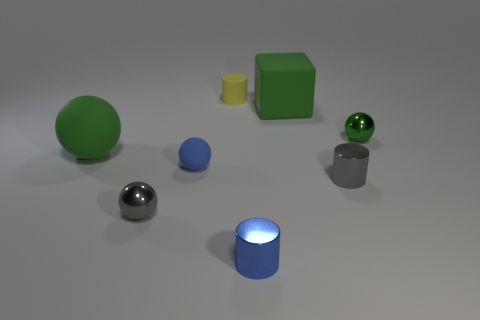There is a large thing to the left of the small shiny sphere that is in front of the tiny blue sphere; what is its material?
Offer a terse response. Rubber. There is a small gray metallic object to the right of the yellow rubber cylinder; is it the same shape as the yellow object?
Offer a terse response. Yes. What number of objects are blue objects or large green matte things that are behind the large matte sphere?
Your response must be concise. 3. Are there fewer yellow cubes than blue cylinders?
Keep it short and to the point. Yes. Are there more cylinders than small blue balls?
Provide a short and direct response. Yes. How many other things are the same material as the large cube?
Provide a succinct answer. 3. There is a big object that is in front of the metallic sphere that is to the right of the cube; how many green metallic balls are in front of it?
Keep it short and to the point. 0. How many metallic objects are either gray spheres or tiny cylinders?
Offer a very short reply. 3. There is a green sphere that is left of the small green metallic ball right of the blue rubber sphere; what size is it?
Your answer should be very brief. Large. There is a large object that is in front of the tiny green metallic sphere; does it have the same color as the metal sphere on the right side of the yellow cylinder?
Keep it short and to the point. Yes. 